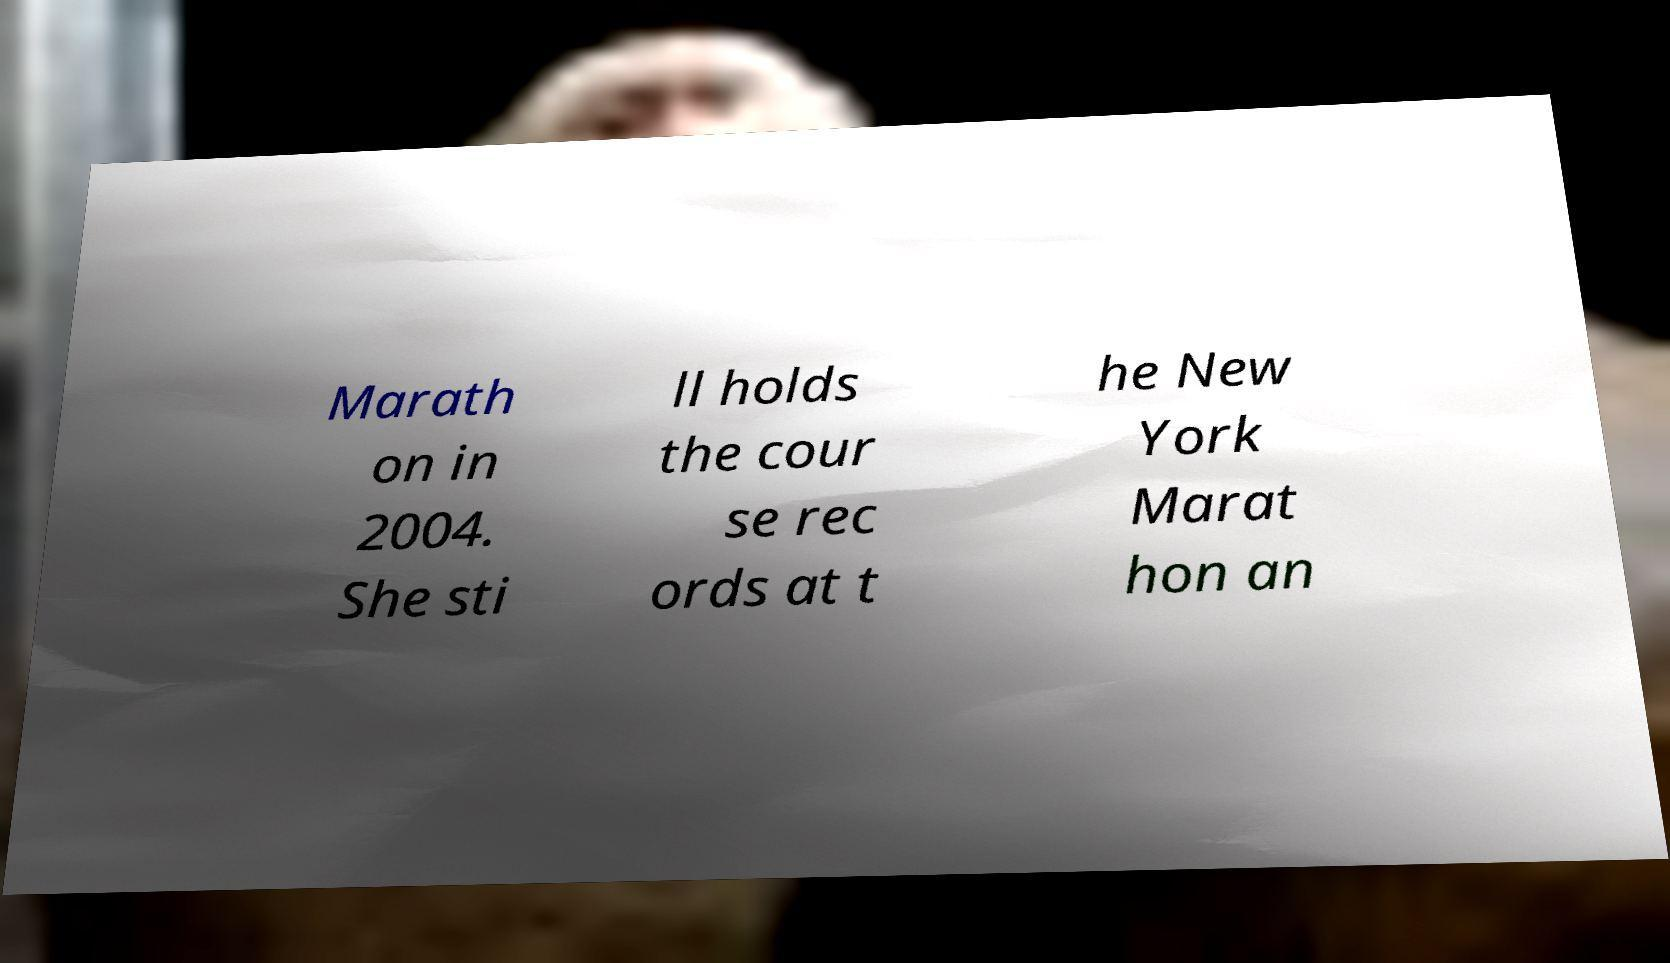What messages or text are displayed in this image? I need them in a readable, typed format. Marath on in 2004. She sti ll holds the cour se rec ords at t he New York Marat hon an 